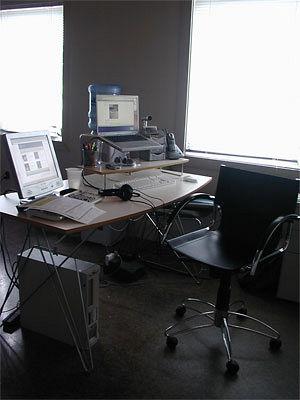Is this desk inside its own office, or is it in a cubicle?
Give a very brief answer. Office. Are the monitors on?
Quick response, please. Yes. Can this chair roll?
Quick response, please. Yes. What is placed on the floor in the office?
Be succinct. Computer. Is this a laptop?
Write a very short answer. Yes. 